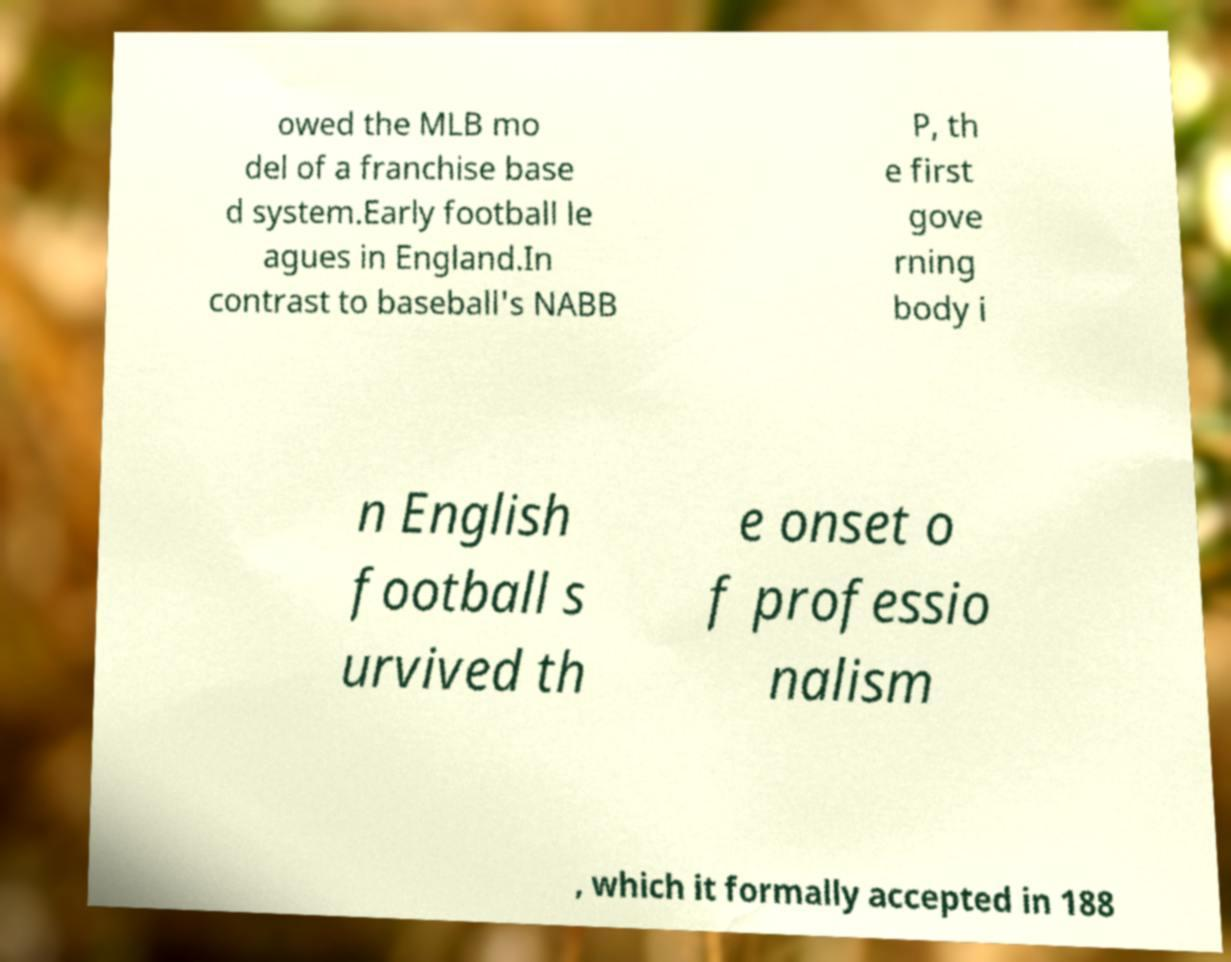Can you read and provide the text displayed in the image?This photo seems to have some interesting text. Can you extract and type it out for me? owed the MLB mo del of a franchise base d system.Early football le agues in England.In contrast to baseball's NABB P, th e first gove rning body i n English football s urvived th e onset o f professio nalism , which it formally accepted in 188 